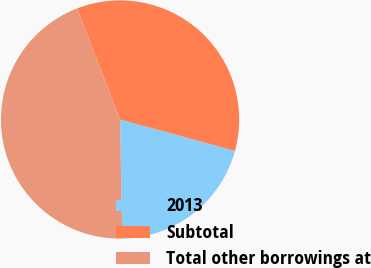Convert chart to OTSL. <chart><loc_0><loc_0><loc_500><loc_500><pie_chart><fcel>2013<fcel>Subtotal<fcel>Total other borrowings at<nl><fcel>20.47%<fcel>35.13%<fcel>44.4%<nl></chart> 